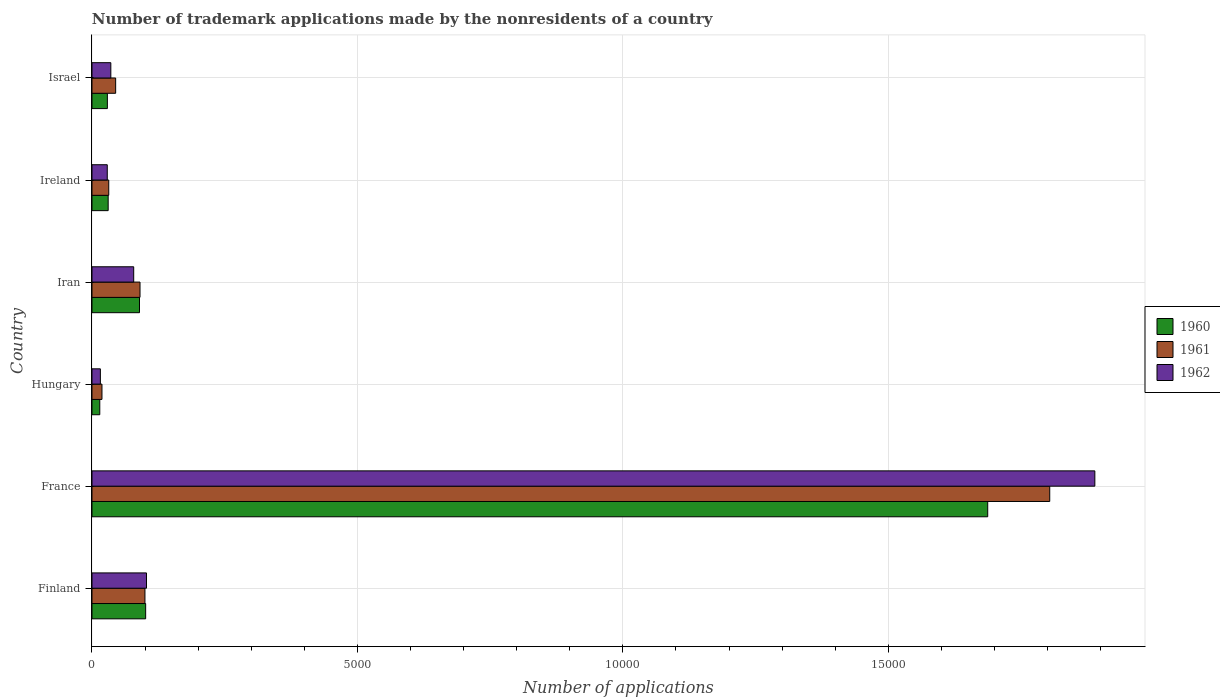Are the number of bars per tick equal to the number of legend labels?
Provide a short and direct response. Yes. Are the number of bars on each tick of the Y-axis equal?
Your response must be concise. Yes. What is the label of the 2nd group of bars from the top?
Make the answer very short. Ireland. In how many cases, is the number of bars for a given country not equal to the number of legend labels?
Offer a terse response. 0. What is the number of trademark applications made by the nonresidents in 1960 in France?
Offer a terse response. 1.69e+04. Across all countries, what is the maximum number of trademark applications made by the nonresidents in 1961?
Your answer should be compact. 1.80e+04. Across all countries, what is the minimum number of trademark applications made by the nonresidents in 1962?
Offer a terse response. 158. In which country was the number of trademark applications made by the nonresidents in 1961 minimum?
Your response must be concise. Hungary. What is the total number of trademark applications made by the nonresidents in 1961 in the graph?
Keep it short and to the point. 2.09e+04. What is the difference between the number of trademark applications made by the nonresidents in 1961 in Hungary and that in Iran?
Your response must be concise. -717. What is the difference between the number of trademark applications made by the nonresidents in 1961 in Ireland and the number of trademark applications made by the nonresidents in 1960 in Finland?
Make the answer very short. -695. What is the average number of trademark applications made by the nonresidents in 1961 per country?
Your answer should be compact. 3482.5. In how many countries, is the number of trademark applications made by the nonresidents in 1962 greater than 5000 ?
Your response must be concise. 1. What is the ratio of the number of trademark applications made by the nonresidents in 1962 in Finland to that in Ireland?
Give a very brief answer. 3.57. Is the number of trademark applications made by the nonresidents in 1961 in Finland less than that in Israel?
Offer a terse response. No. Is the difference between the number of trademark applications made by the nonresidents in 1961 in Iran and Israel greater than the difference between the number of trademark applications made by the nonresidents in 1960 in Iran and Israel?
Make the answer very short. No. What is the difference between the highest and the second highest number of trademark applications made by the nonresidents in 1960?
Your answer should be compact. 1.59e+04. What is the difference between the highest and the lowest number of trademark applications made by the nonresidents in 1961?
Give a very brief answer. 1.79e+04. In how many countries, is the number of trademark applications made by the nonresidents in 1960 greater than the average number of trademark applications made by the nonresidents in 1960 taken over all countries?
Keep it short and to the point. 1. Is the sum of the number of trademark applications made by the nonresidents in 1961 in Iran and Ireland greater than the maximum number of trademark applications made by the nonresidents in 1962 across all countries?
Make the answer very short. No. What does the 3rd bar from the bottom in Hungary represents?
Keep it short and to the point. 1962. Is it the case that in every country, the sum of the number of trademark applications made by the nonresidents in 1962 and number of trademark applications made by the nonresidents in 1961 is greater than the number of trademark applications made by the nonresidents in 1960?
Offer a very short reply. Yes. Are all the bars in the graph horizontal?
Provide a short and direct response. Yes. Does the graph contain any zero values?
Your answer should be compact. No. How many legend labels are there?
Your response must be concise. 3. What is the title of the graph?
Your answer should be compact. Number of trademark applications made by the nonresidents of a country. What is the label or title of the X-axis?
Offer a terse response. Number of applications. What is the Number of applications in 1960 in Finland?
Give a very brief answer. 1011. What is the Number of applications in 1961 in Finland?
Your response must be concise. 998. What is the Number of applications in 1962 in Finland?
Offer a very short reply. 1027. What is the Number of applications of 1960 in France?
Offer a terse response. 1.69e+04. What is the Number of applications of 1961 in France?
Offer a terse response. 1.80e+04. What is the Number of applications in 1962 in France?
Your answer should be compact. 1.89e+04. What is the Number of applications of 1960 in Hungary?
Make the answer very short. 147. What is the Number of applications of 1961 in Hungary?
Offer a terse response. 188. What is the Number of applications in 1962 in Hungary?
Ensure brevity in your answer.  158. What is the Number of applications in 1960 in Iran?
Offer a very short reply. 895. What is the Number of applications of 1961 in Iran?
Ensure brevity in your answer.  905. What is the Number of applications in 1962 in Iran?
Provide a succinct answer. 786. What is the Number of applications in 1960 in Ireland?
Ensure brevity in your answer.  305. What is the Number of applications of 1961 in Ireland?
Keep it short and to the point. 316. What is the Number of applications of 1962 in Ireland?
Your response must be concise. 288. What is the Number of applications in 1960 in Israel?
Ensure brevity in your answer.  290. What is the Number of applications in 1961 in Israel?
Provide a short and direct response. 446. What is the Number of applications in 1962 in Israel?
Make the answer very short. 355. Across all countries, what is the maximum Number of applications in 1960?
Give a very brief answer. 1.69e+04. Across all countries, what is the maximum Number of applications in 1961?
Make the answer very short. 1.80e+04. Across all countries, what is the maximum Number of applications of 1962?
Provide a succinct answer. 1.89e+04. Across all countries, what is the minimum Number of applications of 1960?
Your answer should be compact. 147. Across all countries, what is the minimum Number of applications in 1961?
Your response must be concise. 188. Across all countries, what is the minimum Number of applications in 1962?
Your answer should be compact. 158. What is the total Number of applications in 1960 in the graph?
Keep it short and to the point. 1.95e+04. What is the total Number of applications of 1961 in the graph?
Provide a short and direct response. 2.09e+04. What is the total Number of applications of 1962 in the graph?
Offer a very short reply. 2.15e+04. What is the difference between the Number of applications of 1960 in Finland and that in France?
Offer a very short reply. -1.59e+04. What is the difference between the Number of applications in 1961 in Finland and that in France?
Offer a terse response. -1.70e+04. What is the difference between the Number of applications of 1962 in Finland and that in France?
Your answer should be very brief. -1.79e+04. What is the difference between the Number of applications of 1960 in Finland and that in Hungary?
Offer a very short reply. 864. What is the difference between the Number of applications in 1961 in Finland and that in Hungary?
Provide a succinct answer. 810. What is the difference between the Number of applications of 1962 in Finland and that in Hungary?
Your response must be concise. 869. What is the difference between the Number of applications in 1960 in Finland and that in Iran?
Your answer should be very brief. 116. What is the difference between the Number of applications of 1961 in Finland and that in Iran?
Offer a terse response. 93. What is the difference between the Number of applications of 1962 in Finland and that in Iran?
Your answer should be compact. 241. What is the difference between the Number of applications in 1960 in Finland and that in Ireland?
Provide a succinct answer. 706. What is the difference between the Number of applications in 1961 in Finland and that in Ireland?
Offer a terse response. 682. What is the difference between the Number of applications of 1962 in Finland and that in Ireland?
Provide a succinct answer. 739. What is the difference between the Number of applications in 1960 in Finland and that in Israel?
Your response must be concise. 721. What is the difference between the Number of applications of 1961 in Finland and that in Israel?
Keep it short and to the point. 552. What is the difference between the Number of applications of 1962 in Finland and that in Israel?
Your answer should be very brief. 672. What is the difference between the Number of applications of 1960 in France and that in Hungary?
Make the answer very short. 1.67e+04. What is the difference between the Number of applications in 1961 in France and that in Hungary?
Provide a succinct answer. 1.79e+04. What is the difference between the Number of applications in 1962 in France and that in Hungary?
Your response must be concise. 1.87e+04. What is the difference between the Number of applications of 1960 in France and that in Iran?
Your response must be concise. 1.60e+04. What is the difference between the Number of applications in 1961 in France and that in Iran?
Offer a terse response. 1.71e+04. What is the difference between the Number of applications of 1962 in France and that in Iran?
Keep it short and to the point. 1.81e+04. What is the difference between the Number of applications in 1960 in France and that in Ireland?
Your answer should be compact. 1.66e+04. What is the difference between the Number of applications in 1961 in France and that in Ireland?
Your answer should be compact. 1.77e+04. What is the difference between the Number of applications of 1962 in France and that in Ireland?
Keep it short and to the point. 1.86e+04. What is the difference between the Number of applications of 1960 in France and that in Israel?
Ensure brevity in your answer.  1.66e+04. What is the difference between the Number of applications of 1961 in France and that in Israel?
Your answer should be very brief. 1.76e+04. What is the difference between the Number of applications in 1962 in France and that in Israel?
Keep it short and to the point. 1.85e+04. What is the difference between the Number of applications of 1960 in Hungary and that in Iran?
Your answer should be very brief. -748. What is the difference between the Number of applications in 1961 in Hungary and that in Iran?
Make the answer very short. -717. What is the difference between the Number of applications in 1962 in Hungary and that in Iran?
Offer a terse response. -628. What is the difference between the Number of applications of 1960 in Hungary and that in Ireland?
Give a very brief answer. -158. What is the difference between the Number of applications of 1961 in Hungary and that in Ireland?
Provide a succinct answer. -128. What is the difference between the Number of applications in 1962 in Hungary and that in Ireland?
Your answer should be compact. -130. What is the difference between the Number of applications of 1960 in Hungary and that in Israel?
Provide a short and direct response. -143. What is the difference between the Number of applications in 1961 in Hungary and that in Israel?
Offer a very short reply. -258. What is the difference between the Number of applications in 1962 in Hungary and that in Israel?
Your answer should be very brief. -197. What is the difference between the Number of applications of 1960 in Iran and that in Ireland?
Your response must be concise. 590. What is the difference between the Number of applications of 1961 in Iran and that in Ireland?
Offer a terse response. 589. What is the difference between the Number of applications of 1962 in Iran and that in Ireland?
Ensure brevity in your answer.  498. What is the difference between the Number of applications of 1960 in Iran and that in Israel?
Provide a short and direct response. 605. What is the difference between the Number of applications of 1961 in Iran and that in Israel?
Ensure brevity in your answer.  459. What is the difference between the Number of applications in 1962 in Iran and that in Israel?
Your answer should be very brief. 431. What is the difference between the Number of applications of 1960 in Ireland and that in Israel?
Your answer should be very brief. 15. What is the difference between the Number of applications of 1961 in Ireland and that in Israel?
Offer a terse response. -130. What is the difference between the Number of applications in 1962 in Ireland and that in Israel?
Provide a succinct answer. -67. What is the difference between the Number of applications in 1960 in Finland and the Number of applications in 1961 in France?
Offer a very short reply. -1.70e+04. What is the difference between the Number of applications in 1960 in Finland and the Number of applications in 1962 in France?
Offer a very short reply. -1.79e+04. What is the difference between the Number of applications in 1961 in Finland and the Number of applications in 1962 in France?
Give a very brief answer. -1.79e+04. What is the difference between the Number of applications in 1960 in Finland and the Number of applications in 1961 in Hungary?
Offer a terse response. 823. What is the difference between the Number of applications in 1960 in Finland and the Number of applications in 1962 in Hungary?
Provide a short and direct response. 853. What is the difference between the Number of applications of 1961 in Finland and the Number of applications of 1962 in Hungary?
Offer a terse response. 840. What is the difference between the Number of applications of 1960 in Finland and the Number of applications of 1961 in Iran?
Keep it short and to the point. 106. What is the difference between the Number of applications of 1960 in Finland and the Number of applications of 1962 in Iran?
Offer a very short reply. 225. What is the difference between the Number of applications in 1961 in Finland and the Number of applications in 1962 in Iran?
Provide a succinct answer. 212. What is the difference between the Number of applications of 1960 in Finland and the Number of applications of 1961 in Ireland?
Ensure brevity in your answer.  695. What is the difference between the Number of applications in 1960 in Finland and the Number of applications in 1962 in Ireland?
Provide a short and direct response. 723. What is the difference between the Number of applications of 1961 in Finland and the Number of applications of 1962 in Ireland?
Provide a short and direct response. 710. What is the difference between the Number of applications of 1960 in Finland and the Number of applications of 1961 in Israel?
Ensure brevity in your answer.  565. What is the difference between the Number of applications of 1960 in Finland and the Number of applications of 1962 in Israel?
Offer a very short reply. 656. What is the difference between the Number of applications in 1961 in Finland and the Number of applications in 1962 in Israel?
Provide a succinct answer. 643. What is the difference between the Number of applications in 1960 in France and the Number of applications in 1961 in Hungary?
Make the answer very short. 1.67e+04. What is the difference between the Number of applications of 1960 in France and the Number of applications of 1962 in Hungary?
Offer a very short reply. 1.67e+04. What is the difference between the Number of applications in 1961 in France and the Number of applications in 1962 in Hungary?
Provide a short and direct response. 1.79e+04. What is the difference between the Number of applications of 1960 in France and the Number of applications of 1961 in Iran?
Your answer should be very brief. 1.60e+04. What is the difference between the Number of applications in 1960 in France and the Number of applications in 1962 in Iran?
Offer a terse response. 1.61e+04. What is the difference between the Number of applications in 1961 in France and the Number of applications in 1962 in Iran?
Your answer should be very brief. 1.73e+04. What is the difference between the Number of applications of 1960 in France and the Number of applications of 1961 in Ireland?
Provide a short and direct response. 1.66e+04. What is the difference between the Number of applications of 1960 in France and the Number of applications of 1962 in Ireland?
Your answer should be very brief. 1.66e+04. What is the difference between the Number of applications in 1961 in France and the Number of applications in 1962 in Ireland?
Offer a terse response. 1.78e+04. What is the difference between the Number of applications of 1960 in France and the Number of applications of 1961 in Israel?
Offer a terse response. 1.64e+04. What is the difference between the Number of applications of 1960 in France and the Number of applications of 1962 in Israel?
Give a very brief answer. 1.65e+04. What is the difference between the Number of applications of 1961 in France and the Number of applications of 1962 in Israel?
Ensure brevity in your answer.  1.77e+04. What is the difference between the Number of applications of 1960 in Hungary and the Number of applications of 1961 in Iran?
Provide a succinct answer. -758. What is the difference between the Number of applications of 1960 in Hungary and the Number of applications of 1962 in Iran?
Ensure brevity in your answer.  -639. What is the difference between the Number of applications of 1961 in Hungary and the Number of applications of 1962 in Iran?
Give a very brief answer. -598. What is the difference between the Number of applications of 1960 in Hungary and the Number of applications of 1961 in Ireland?
Your answer should be very brief. -169. What is the difference between the Number of applications of 1960 in Hungary and the Number of applications of 1962 in Ireland?
Offer a very short reply. -141. What is the difference between the Number of applications of 1961 in Hungary and the Number of applications of 1962 in Ireland?
Offer a very short reply. -100. What is the difference between the Number of applications of 1960 in Hungary and the Number of applications of 1961 in Israel?
Offer a terse response. -299. What is the difference between the Number of applications in 1960 in Hungary and the Number of applications in 1962 in Israel?
Your answer should be compact. -208. What is the difference between the Number of applications in 1961 in Hungary and the Number of applications in 1962 in Israel?
Your response must be concise. -167. What is the difference between the Number of applications of 1960 in Iran and the Number of applications of 1961 in Ireland?
Offer a very short reply. 579. What is the difference between the Number of applications in 1960 in Iran and the Number of applications in 1962 in Ireland?
Give a very brief answer. 607. What is the difference between the Number of applications of 1961 in Iran and the Number of applications of 1962 in Ireland?
Your answer should be compact. 617. What is the difference between the Number of applications of 1960 in Iran and the Number of applications of 1961 in Israel?
Ensure brevity in your answer.  449. What is the difference between the Number of applications in 1960 in Iran and the Number of applications in 1962 in Israel?
Ensure brevity in your answer.  540. What is the difference between the Number of applications of 1961 in Iran and the Number of applications of 1962 in Israel?
Provide a short and direct response. 550. What is the difference between the Number of applications in 1960 in Ireland and the Number of applications in 1961 in Israel?
Keep it short and to the point. -141. What is the difference between the Number of applications in 1961 in Ireland and the Number of applications in 1962 in Israel?
Provide a short and direct response. -39. What is the average Number of applications of 1960 per country?
Ensure brevity in your answer.  3253.67. What is the average Number of applications of 1961 per country?
Your answer should be very brief. 3482.5. What is the average Number of applications of 1962 per country?
Your answer should be very brief. 3584.33. What is the difference between the Number of applications of 1961 and Number of applications of 1962 in Finland?
Offer a very short reply. -29. What is the difference between the Number of applications of 1960 and Number of applications of 1961 in France?
Offer a very short reply. -1168. What is the difference between the Number of applications in 1960 and Number of applications in 1962 in France?
Provide a succinct answer. -2018. What is the difference between the Number of applications in 1961 and Number of applications in 1962 in France?
Your response must be concise. -850. What is the difference between the Number of applications of 1960 and Number of applications of 1961 in Hungary?
Provide a succinct answer. -41. What is the difference between the Number of applications in 1960 and Number of applications in 1962 in Iran?
Your response must be concise. 109. What is the difference between the Number of applications of 1961 and Number of applications of 1962 in Iran?
Your response must be concise. 119. What is the difference between the Number of applications in 1960 and Number of applications in 1962 in Ireland?
Keep it short and to the point. 17. What is the difference between the Number of applications of 1960 and Number of applications of 1961 in Israel?
Provide a succinct answer. -156. What is the difference between the Number of applications of 1960 and Number of applications of 1962 in Israel?
Offer a very short reply. -65. What is the difference between the Number of applications in 1961 and Number of applications in 1962 in Israel?
Offer a terse response. 91. What is the ratio of the Number of applications of 1960 in Finland to that in France?
Your answer should be very brief. 0.06. What is the ratio of the Number of applications of 1961 in Finland to that in France?
Your answer should be very brief. 0.06. What is the ratio of the Number of applications of 1962 in Finland to that in France?
Offer a terse response. 0.05. What is the ratio of the Number of applications of 1960 in Finland to that in Hungary?
Provide a short and direct response. 6.88. What is the ratio of the Number of applications of 1961 in Finland to that in Hungary?
Your answer should be compact. 5.31. What is the ratio of the Number of applications in 1960 in Finland to that in Iran?
Your answer should be very brief. 1.13. What is the ratio of the Number of applications of 1961 in Finland to that in Iran?
Provide a short and direct response. 1.1. What is the ratio of the Number of applications in 1962 in Finland to that in Iran?
Ensure brevity in your answer.  1.31. What is the ratio of the Number of applications in 1960 in Finland to that in Ireland?
Offer a terse response. 3.31. What is the ratio of the Number of applications in 1961 in Finland to that in Ireland?
Provide a short and direct response. 3.16. What is the ratio of the Number of applications in 1962 in Finland to that in Ireland?
Your answer should be compact. 3.57. What is the ratio of the Number of applications of 1960 in Finland to that in Israel?
Provide a succinct answer. 3.49. What is the ratio of the Number of applications in 1961 in Finland to that in Israel?
Your answer should be very brief. 2.24. What is the ratio of the Number of applications of 1962 in Finland to that in Israel?
Provide a succinct answer. 2.89. What is the ratio of the Number of applications of 1960 in France to that in Hungary?
Your answer should be compact. 114.79. What is the ratio of the Number of applications in 1961 in France to that in Hungary?
Your response must be concise. 95.97. What is the ratio of the Number of applications of 1962 in France to that in Hungary?
Your answer should be compact. 119.57. What is the ratio of the Number of applications of 1960 in France to that in Iran?
Keep it short and to the point. 18.85. What is the ratio of the Number of applications in 1961 in France to that in Iran?
Your response must be concise. 19.94. What is the ratio of the Number of applications in 1962 in France to that in Iran?
Ensure brevity in your answer.  24.04. What is the ratio of the Number of applications of 1960 in France to that in Ireland?
Your answer should be compact. 55.32. What is the ratio of the Number of applications in 1961 in France to that in Ireland?
Provide a succinct answer. 57.09. What is the ratio of the Number of applications of 1962 in France to that in Ireland?
Provide a short and direct response. 65.6. What is the ratio of the Number of applications in 1960 in France to that in Israel?
Offer a very short reply. 58.19. What is the ratio of the Number of applications in 1961 in France to that in Israel?
Your answer should be very brief. 40.45. What is the ratio of the Number of applications in 1962 in France to that in Israel?
Offer a terse response. 53.22. What is the ratio of the Number of applications of 1960 in Hungary to that in Iran?
Your response must be concise. 0.16. What is the ratio of the Number of applications in 1961 in Hungary to that in Iran?
Provide a succinct answer. 0.21. What is the ratio of the Number of applications in 1962 in Hungary to that in Iran?
Provide a short and direct response. 0.2. What is the ratio of the Number of applications in 1960 in Hungary to that in Ireland?
Offer a very short reply. 0.48. What is the ratio of the Number of applications of 1961 in Hungary to that in Ireland?
Your answer should be very brief. 0.59. What is the ratio of the Number of applications in 1962 in Hungary to that in Ireland?
Your response must be concise. 0.55. What is the ratio of the Number of applications of 1960 in Hungary to that in Israel?
Your response must be concise. 0.51. What is the ratio of the Number of applications in 1961 in Hungary to that in Israel?
Your answer should be compact. 0.42. What is the ratio of the Number of applications of 1962 in Hungary to that in Israel?
Your answer should be very brief. 0.45. What is the ratio of the Number of applications in 1960 in Iran to that in Ireland?
Your answer should be compact. 2.93. What is the ratio of the Number of applications of 1961 in Iran to that in Ireland?
Provide a succinct answer. 2.86. What is the ratio of the Number of applications in 1962 in Iran to that in Ireland?
Give a very brief answer. 2.73. What is the ratio of the Number of applications in 1960 in Iran to that in Israel?
Make the answer very short. 3.09. What is the ratio of the Number of applications of 1961 in Iran to that in Israel?
Provide a succinct answer. 2.03. What is the ratio of the Number of applications in 1962 in Iran to that in Israel?
Provide a succinct answer. 2.21. What is the ratio of the Number of applications in 1960 in Ireland to that in Israel?
Offer a terse response. 1.05. What is the ratio of the Number of applications in 1961 in Ireland to that in Israel?
Ensure brevity in your answer.  0.71. What is the ratio of the Number of applications in 1962 in Ireland to that in Israel?
Offer a very short reply. 0.81. What is the difference between the highest and the second highest Number of applications in 1960?
Provide a short and direct response. 1.59e+04. What is the difference between the highest and the second highest Number of applications of 1961?
Your answer should be very brief. 1.70e+04. What is the difference between the highest and the second highest Number of applications of 1962?
Provide a succinct answer. 1.79e+04. What is the difference between the highest and the lowest Number of applications of 1960?
Make the answer very short. 1.67e+04. What is the difference between the highest and the lowest Number of applications in 1961?
Offer a very short reply. 1.79e+04. What is the difference between the highest and the lowest Number of applications of 1962?
Provide a short and direct response. 1.87e+04. 